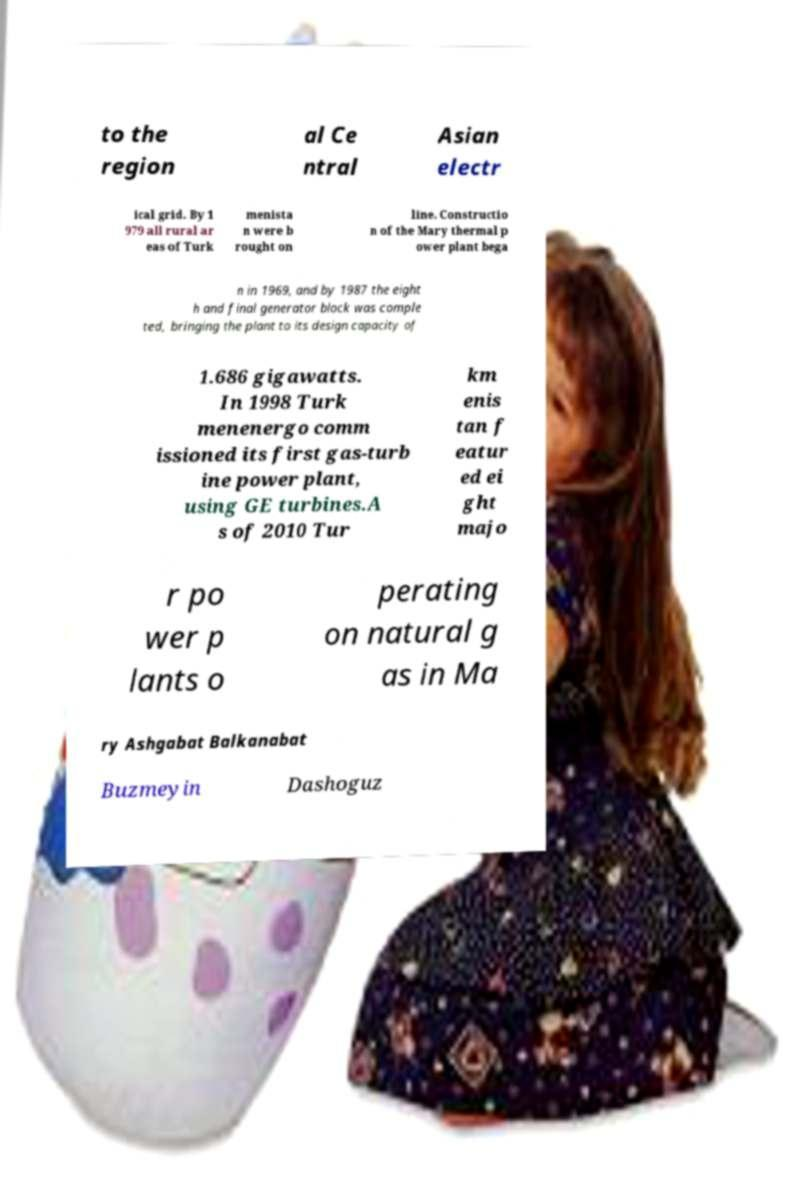What messages or text are displayed in this image? I need them in a readable, typed format. to the region al Ce ntral Asian electr ical grid. By 1 979 all rural ar eas of Turk menista n were b rought on line. Constructio n of the Mary thermal p ower plant bega n in 1969, and by 1987 the eight h and final generator block was comple ted, bringing the plant to its design capacity of 1.686 gigawatts. In 1998 Turk menenergo comm issioned its first gas-turb ine power plant, using GE turbines.A s of 2010 Tur km enis tan f eatur ed ei ght majo r po wer p lants o perating on natural g as in Ma ry Ashgabat Balkanabat Buzmeyin Dashoguz 